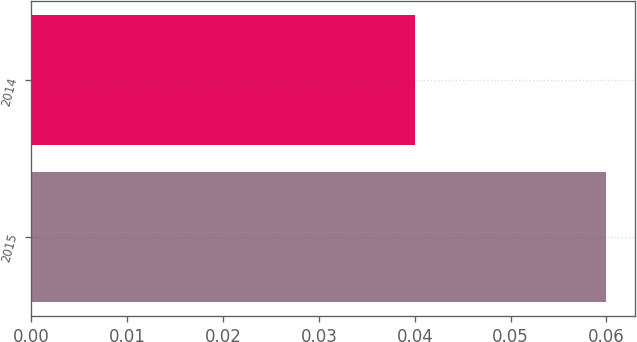Convert chart to OTSL. <chart><loc_0><loc_0><loc_500><loc_500><bar_chart><fcel>2015<fcel>2014<nl><fcel>0.06<fcel>0.04<nl></chart> 